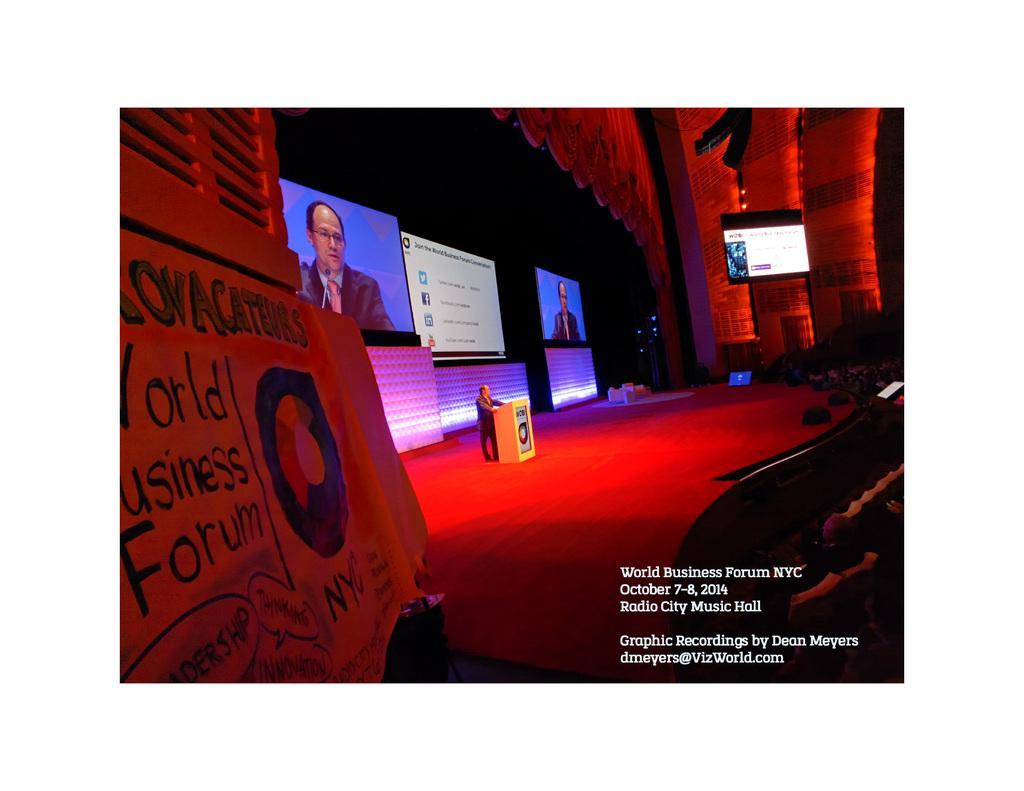Describe this image in one or two sentences. This image is taken in an auditorium where we can see on the left, there is a banner, a stage, a podium, a man, few screens and a red light. 